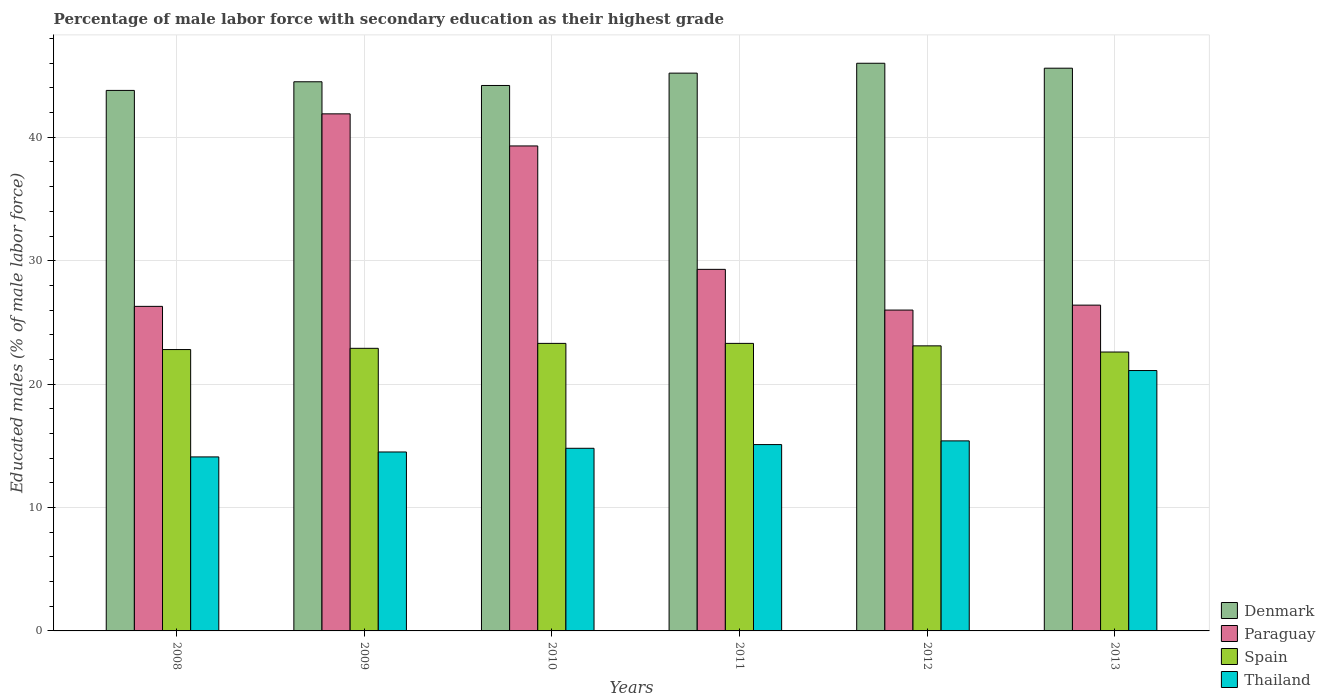How many different coloured bars are there?
Offer a terse response. 4. How many groups of bars are there?
Your response must be concise. 6. Are the number of bars per tick equal to the number of legend labels?
Your answer should be compact. Yes. How many bars are there on the 5th tick from the left?
Your response must be concise. 4. What is the label of the 5th group of bars from the left?
Provide a short and direct response. 2012. What is the percentage of male labor force with secondary education in Paraguay in 2008?
Make the answer very short. 26.3. Across all years, what is the minimum percentage of male labor force with secondary education in Thailand?
Your answer should be compact. 14.1. In which year was the percentage of male labor force with secondary education in Paraguay maximum?
Your answer should be very brief. 2009. In which year was the percentage of male labor force with secondary education in Spain minimum?
Keep it short and to the point. 2013. What is the total percentage of male labor force with secondary education in Denmark in the graph?
Make the answer very short. 269.3. What is the difference between the percentage of male labor force with secondary education in Thailand in 2010 and that in 2011?
Ensure brevity in your answer.  -0.3. What is the difference between the percentage of male labor force with secondary education in Denmark in 2010 and the percentage of male labor force with secondary education in Spain in 2013?
Offer a terse response. 21.6. What is the average percentage of male labor force with secondary education in Denmark per year?
Offer a very short reply. 44.88. In the year 2012, what is the difference between the percentage of male labor force with secondary education in Denmark and percentage of male labor force with secondary education in Spain?
Ensure brevity in your answer.  22.9. What is the ratio of the percentage of male labor force with secondary education in Denmark in 2012 to that in 2013?
Your answer should be compact. 1.01. Is the percentage of male labor force with secondary education in Denmark in 2009 less than that in 2012?
Your response must be concise. Yes. What is the difference between the highest and the second highest percentage of male labor force with secondary education in Thailand?
Offer a terse response. 5.7. What is the difference between the highest and the lowest percentage of male labor force with secondary education in Spain?
Keep it short and to the point. 0.7. Is the sum of the percentage of male labor force with secondary education in Paraguay in 2010 and 2013 greater than the maximum percentage of male labor force with secondary education in Spain across all years?
Your response must be concise. Yes. What does the 2nd bar from the right in 2013 represents?
Offer a very short reply. Spain. Is it the case that in every year, the sum of the percentage of male labor force with secondary education in Denmark and percentage of male labor force with secondary education in Thailand is greater than the percentage of male labor force with secondary education in Spain?
Your answer should be compact. Yes. Are all the bars in the graph horizontal?
Keep it short and to the point. No. Are the values on the major ticks of Y-axis written in scientific E-notation?
Your answer should be compact. No. What is the title of the graph?
Your response must be concise. Percentage of male labor force with secondary education as their highest grade. What is the label or title of the Y-axis?
Provide a short and direct response. Educated males (% of male labor force). What is the Educated males (% of male labor force) of Denmark in 2008?
Your answer should be very brief. 43.8. What is the Educated males (% of male labor force) of Paraguay in 2008?
Your answer should be compact. 26.3. What is the Educated males (% of male labor force) in Spain in 2008?
Keep it short and to the point. 22.8. What is the Educated males (% of male labor force) in Thailand in 2008?
Your response must be concise. 14.1. What is the Educated males (% of male labor force) in Denmark in 2009?
Keep it short and to the point. 44.5. What is the Educated males (% of male labor force) in Paraguay in 2009?
Make the answer very short. 41.9. What is the Educated males (% of male labor force) of Spain in 2009?
Ensure brevity in your answer.  22.9. What is the Educated males (% of male labor force) in Thailand in 2009?
Offer a very short reply. 14.5. What is the Educated males (% of male labor force) of Denmark in 2010?
Make the answer very short. 44.2. What is the Educated males (% of male labor force) of Paraguay in 2010?
Offer a very short reply. 39.3. What is the Educated males (% of male labor force) in Spain in 2010?
Offer a terse response. 23.3. What is the Educated males (% of male labor force) in Thailand in 2010?
Provide a succinct answer. 14.8. What is the Educated males (% of male labor force) of Denmark in 2011?
Offer a very short reply. 45.2. What is the Educated males (% of male labor force) in Paraguay in 2011?
Give a very brief answer. 29.3. What is the Educated males (% of male labor force) in Spain in 2011?
Keep it short and to the point. 23.3. What is the Educated males (% of male labor force) in Thailand in 2011?
Give a very brief answer. 15.1. What is the Educated males (% of male labor force) of Spain in 2012?
Offer a very short reply. 23.1. What is the Educated males (% of male labor force) in Thailand in 2012?
Ensure brevity in your answer.  15.4. What is the Educated males (% of male labor force) of Denmark in 2013?
Give a very brief answer. 45.6. What is the Educated males (% of male labor force) of Paraguay in 2013?
Provide a short and direct response. 26.4. What is the Educated males (% of male labor force) in Spain in 2013?
Offer a terse response. 22.6. What is the Educated males (% of male labor force) in Thailand in 2013?
Offer a terse response. 21.1. Across all years, what is the maximum Educated males (% of male labor force) in Paraguay?
Provide a short and direct response. 41.9. Across all years, what is the maximum Educated males (% of male labor force) in Spain?
Your answer should be very brief. 23.3. Across all years, what is the maximum Educated males (% of male labor force) in Thailand?
Offer a terse response. 21.1. Across all years, what is the minimum Educated males (% of male labor force) in Denmark?
Provide a short and direct response. 43.8. Across all years, what is the minimum Educated males (% of male labor force) in Paraguay?
Provide a succinct answer. 26. Across all years, what is the minimum Educated males (% of male labor force) of Spain?
Your answer should be compact. 22.6. Across all years, what is the minimum Educated males (% of male labor force) in Thailand?
Offer a terse response. 14.1. What is the total Educated males (% of male labor force) of Denmark in the graph?
Offer a very short reply. 269.3. What is the total Educated males (% of male labor force) of Paraguay in the graph?
Make the answer very short. 189.2. What is the total Educated males (% of male labor force) in Spain in the graph?
Your answer should be very brief. 138. What is the difference between the Educated males (% of male labor force) in Denmark in 2008 and that in 2009?
Give a very brief answer. -0.7. What is the difference between the Educated males (% of male labor force) of Paraguay in 2008 and that in 2009?
Offer a terse response. -15.6. What is the difference between the Educated males (% of male labor force) in Thailand in 2008 and that in 2009?
Give a very brief answer. -0.4. What is the difference between the Educated males (% of male labor force) of Paraguay in 2008 and that in 2010?
Your response must be concise. -13. What is the difference between the Educated males (% of male labor force) in Spain in 2008 and that in 2010?
Your answer should be compact. -0.5. What is the difference between the Educated males (% of male labor force) of Denmark in 2008 and that in 2011?
Your answer should be compact. -1.4. What is the difference between the Educated males (% of male labor force) of Paraguay in 2008 and that in 2011?
Provide a short and direct response. -3. What is the difference between the Educated males (% of male labor force) in Spain in 2008 and that in 2011?
Offer a very short reply. -0.5. What is the difference between the Educated males (% of male labor force) in Thailand in 2008 and that in 2011?
Ensure brevity in your answer.  -1. What is the difference between the Educated males (% of male labor force) of Denmark in 2008 and that in 2012?
Make the answer very short. -2.2. What is the difference between the Educated males (% of male labor force) of Thailand in 2008 and that in 2012?
Your response must be concise. -1.3. What is the difference between the Educated males (% of male labor force) of Denmark in 2008 and that in 2013?
Provide a succinct answer. -1.8. What is the difference between the Educated males (% of male labor force) of Paraguay in 2008 and that in 2013?
Provide a short and direct response. -0.1. What is the difference between the Educated males (% of male labor force) of Spain in 2008 and that in 2013?
Offer a terse response. 0.2. What is the difference between the Educated males (% of male labor force) of Thailand in 2008 and that in 2013?
Your response must be concise. -7. What is the difference between the Educated males (% of male labor force) in Denmark in 2009 and that in 2010?
Your answer should be very brief. 0.3. What is the difference between the Educated males (% of male labor force) in Thailand in 2009 and that in 2010?
Offer a very short reply. -0.3. What is the difference between the Educated males (% of male labor force) of Paraguay in 2009 and that in 2011?
Your response must be concise. 12.6. What is the difference between the Educated males (% of male labor force) of Spain in 2009 and that in 2011?
Ensure brevity in your answer.  -0.4. What is the difference between the Educated males (% of male labor force) in Thailand in 2009 and that in 2011?
Offer a very short reply. -0.6. What is the difference between the Educated males (% of male labor force) of Spain in 2009 and that in 2012?
Make the answer very short. -0.2. What is the difference between the Educated males (% of male labor force) of Thailand in 2009 and that in 2012?
Give a very brief answer. -0.9. What is the difference between the Educated males (% of male labor force) of Spain in 2009 and that in 2013?
Your response must be concise. 0.3. What is the difference between the Educated males (% of male labor force) of Thailand in 2010 and that in 2011?
Offer a terse response. -0.3. What is the difference between the Educated males (% of male labor force) of Paraguay in 2010 and that in 2012?
Keep it short and to the point. 13.3. What is the difference between the Educated males (% of male labor force) of Denmark in 2011 and that in 2012?
Give a very brief answer. -0.8. What is the difference between the Educated males (% of male labor force) in Spain in 2011 and that in 2012?
Offer a very short reply. 0.2. What is the difference between the Educated males (% of male labor force) in Paraguay in 2011 and that in 2013?
Offer a very short reply. 2.9. What is the difference between the Educated males (% of male labor force) in Thailand in 2011 and that in 2013?
Provide a succinct answer. -6. What is the difference between the Educated males (% of male labor force) in Denmark in 2012 and that in 2013?
Keep it short and to the point. 0.4. What is the difference between the Educated males (% of male labor force) in Spain in 2012 and that in 2013?
Provide a short and direct response. 0.5. What is the difference between the Educated males (% of male labor force) of Thailand in 2012 and that in 2013?
Give a very brief answer. -5.7. What is the difference between the Educated males (% of male labor force) of Denmark in 2008 and the Educated males (% of male labor force) of Spain in 2009?
Keep it short and to the point. 20.9. What is the difference between the Educated males (% of male labor force) of Denmark in 2008 and the Educated males (% of male labor force) of Thailand in 2009?
Keep it short and to the point. 29.3. What is the difference between the Educated males (% of male labor force) of Paraguay in 2008 and the Educated males (% of male labor force) of Thailand in 2009?
Provide a short and direct response. 11.8. What is the difference between the Educated males (% of male labor force) in Spain in 2008 and the Educated males (% of male labor force) in Thailand in 2009?
Provide a succinct answer. 8.3. What is the difference between the Educated males (% of male labor force) in Denmark in 2008 and the Educated males (% of male labor force) in Paraguay in 2010?
Ensure brevity in your answer.  4.5. What is the difference between the Educated males (% of male labor force) of Paraguay in 2008 and the Educated males (% of male labor force) of Spain in 2010?
Offer a terse response. 3. What is the difference between the Educated males (% of male labor force) of Spain in 2008 and the Educated males (% of male labor force) of Thailand in 2010?
Offer a terse response. 8. What is the difference between the Educated males (% of male labor force) in Denmark in 2008 and the Educated males (% of male labor force) in Thailand in 2011?
Offer a very short reply. 28.7. What is the difference between the Educated males (% of male labor force) in Paraguay in 2008 and the Educated males (% of male labor force) in Spain in 2011?
Ensure brevity in your answer.  3. What is the difference between the Educated males (% of male labor force) in Paraguay in 2008 and the Educated males (% of male labor force) in Thailand in 2011?
Provide a short and direct response. 11.2. What is the difference between the Educated males (% of male labor force) of Spain in 2008 and the Educated males (% of male labor force) of Thailand in 2011?
Make the answer very short. 7.7. What is the difference between the Educated males (% of male labor force) of Denmark in 2008 and the Educated males (% of male labor force) of Spain in 2012?
Provide a short and direct response. 20.7. What is the difference between the Educated males (% of male labor force) of Denmark in 2008 and the Educated males (% of male labor force) of Thailand in 2012?
Give a very brief answer. 28.4. What is the difference between the Educated males (% of male labor force) in Paraguay in 2008 and the Educated males (% of male labor force) in Spain in 2012?
Your answer should be very brief. 3.2. What is the difference between the Educated males (% of male labor force) in Paraguay in 2008 and the Educated males (% of male labor force) in Thailand in 2012?
Provide a succinct answer. 10.9. What is the difference between the Educated males (% of male labor force) of Spain in 2008 and the Educated males (% of male labor force) of Thailand in 2012?
Offer a very short reply. 7.4. What is the difference between the Educated males (% of male labor force) in Denmark in 2008 and the Educated males (% of male labor force) in Spain in 2013?
Ensure brevity in your answer.  21.2. What is the difference between the Educated males (% of male labor force) in Denmark in 2008 and the Educated males (% of male labor force) in Thailand in 2013?
Your answer should be compact. 22.7. What is the difference between the Educated males (% of male labor force) of Denmark in 2009 and the Educated males (% of male labor force) of Spain in 2010?
Your answer should be compact. 21.2. What is the difference between the Educated males (% of male labor force) of Denmark in 2009 and the Educated males (% of male labor force) of Thailand in 2010?
Make the answer very short. 29.7. What is the difference between the Educated males (% of male labor force) of Paraguay in 2009 and the Educated males (% of male labor force) of Spain in 2010?
Keep it short and to the point. 18.6. What is the difference between the Educated males (% of male labor force) in Paraguay in 2009 and the Educated males (% of male labor force) in Thailand in 2010?
Your response must be concise. 27.1. What is the difference between the Educated males (% of male labor force) in Spain in 2009 and the Educated males (% of male labor force) in Thailand in 2010?
Keep it short and to the point. 8.1. What is the difference between the Educated males (% of male labor force) of Denmark in 2009 and the Educated males (% of male labor force) of Spain in 2011?
Provide a short and direct response. 21.2. What is the difference between the Educated males (% of male labor force) of Denmark in 2009 and the Educated males (% of male labor force) of Thailand in 2011?
Keep it short and to the point. 29.4. What is the difference between the Educated males (% of male labor force) of Paraguay in 2009 and the Educated males (% of male labor force) of Thailand in 2011?
Your answer should be compact. 26.8. What is the difference between the Educated males (% of male labor force) of Spain in 2009 and the Educated males (% of male labor force) of Thailand in 2011?
Give a very brief answer. 7.8. What is the difference between the Educated males (% of male labor force) of Denmark in 2009 and the Educated males (% of male labor force) of Paraguay in 2012?
Offer a terse response. 18.5. What is the difference between the Educated males (% of male labor force) in Denmark in 2009 and the Educated males (% of male labor force) in Spain in 2012?
Ensure brevity in your answer.  21.4. What is the difference between the Educated males (% of male labor force) of Denmark in 2009 and the Educated males (% of male labor force) of Thailand in 2012?
Your answer should be very brief. 29.1. What is the difference between the Educated males (% of male labor force) of Paraguay in 2009 and the Educated males (% of male labor force) of Spain in 2012?
Offer a very short reply. 18.8. What is the difference between the Educated males (% of male labor force) in Denmark in 2009 and the Educated males (% of male labor force) in Paraguay in 2013?
Your answer should be compact. 18.1. What is the difference between the Educated males (% of male labor force) of Denmark in 2009 and the Educated males (% of male labor force) of Spain in 2013?
Ensure brevity in your answer.  21.9. What is the difference between the Educated males (% of male labor force) of Denmark in 2009 and the Educated males (% of male labor force) of Thailand in 2013?
Your response must be concise. 23.4. What is the difference between the Educated males (% of male labor force) in Paraguay in 2009 and the Educated males (% of male labor force) in Spain in 2013?
Your answer should be compact. 19.3. What is the difference between the Educated males (% of male labor force) in Paraguay in 2009 and the Educated males (% of male labor force) in Thailand in 2013?
Your answer should be compact. 20.8. What is the difference between the Educated males (% of male labor force) of Spain in 2009 and the Educated males (% of male labor force) of Thailand in 2013?
Your answer should be compact. 1.8. What is the difference between the Educated males (% of male labor force) in Denmark in 2010 and the Educated males (% of male labor force) in Spain in 2011?
Ensure brevity in your answer.  20.9. What is the difference between the Educated males (% of male labor force) of Denmark in 2010 and the Educated males (% of male labor force) of Thailand in 2011?
Ensure brevity in your answer.  29.1. What is the difference between the Educated males (% of male labor force) of Paraguay in 2010 and the Educated males (% of male labor force) of Spain in 2011?
Give a very brief answer. 16. What is the difference between the Educated males (% of male labor force) of Paraguay in 2010 and the Educated males (% of male labor force) of Thailand in 2011?
Offer a terse response. 24.2. What is the difference between the Educated males (% of male labor force) of Spain in 2010 and the Educated males (% of male labor force) of Thailand in 2011?
Provide a succinct answer. 8.2. What is the difference between the Educated males (% of male labor force) in Denmark in 2010 and the Educated males (% of male labor force) in Paraguay in 2012?
Offer a terse response. 18.2. What is the difference between the Educated males (% of male labor force) in Denmark in 2010 and the Educated males (% of male labor force) in Spain in 2012?
Ensure brevity in your answer.  21.1. What is the difference between the Educated males (% of male labor force) of Denmark in 2010 and the Educated males (% of male labor force) of Thailand in 2012?
Keep it short and to the point. 28.8. What is the difference between the Educated males (% of male labor force) in Paraguay in 2010 and the Educated males (% of male labor force) in Thailand in 2012?
Offer a terse response. 23.9. What is the difference between the Educated males (% of male labor force) in Denmark in 2010 and the Educated males (% of male labor force) in Spain in 2013?
Offer a terse response. 21.6. What is the difference between the Educated males (% of male labor force) of Denmark in 2010 and the Educated males (% of male labor force) of Thailand in 2013?
Provide a succinct answer. 23.1. What is the difference between the Educated males (% of male labor force) in Paraguay in 2010 and the Educated males (% of male labor force) in Thailand in 2013?
Make the answer very short. 18.2. What is the difference between the Educated males (% of male labor force) in Spain in 2010 and the Educated males (% of male labor force) in Thailand in 2013?
Give a very brief answer. 2.2. What is the difference between the Educated males (% of male labor force) in Denmark in 2011 and the Educated males (% of male labor force) in Paraguay in 2012?
Your response must be concise. 19.2. What is the difference between the Educated males (% of male labor force) of Denmark in 2011 and the Educated males (% of male labor force) of Spain in 2012?
Offer a very short reply. 22.1. What is the difference between the Educated males (% of male labor force) of Denmark in 2011 and the Educated males (% of male labor force) of Thailand in 2012?
Offer a terse response. 29.8. What is the difference between the Educated males (% of male labor force) in Paraguay in 2011 and the Educated males (% of male labor force) in Spain in 2012?
Offer a very short reply. 6.2. What is the difference between the Educated males (% of male labor force) of Paraguay in 2011 and the Educated males (% of male labor force) of Thailand in 2012?
Ensure brevity in your answer.  13.9. What is the difference between the Educated males (% of male labor force) in Spain in 2011 and the Educated males (% of male labor force) in Thailand in 2012?
Your response must be concise. 7.9. What is the difference between the Educated males (% of male labor force) of Denmark in 2011 and the Educated males (% of male labor force) of Paraguay in 2013?
Offer a terse response. 18.8. What is the difference between the Educated males (% of male labor force) of Denmark in 2011 and the Educated males (% of male labor force) of Spain in 2013?
Offer a very short reply. 22.6. What is the difference between the Educated males (% of male labor force) of Denmark in 2011 and the Educated males (% of male labor force) of Thailand in 2013?
Provide a succinct answer. 24.1. What is the difference between the Educated males (% of male labor force) in Denmark in 2012 and the Educated males (% of male labor force) in Paraguay in 2013?
Your answer should be compact. 19.6. What is the difference between the Educated males (% of male labor force) of Denmark in 2012 and the Educated males (% of male labor force) of Spain in 2013?
Offer a very short reply. 23.4. What is the difference between the Educated males (% of male labor force) of Denmark in 2012 and the Educated males (% of male labor force) of Thailand in 2013?
Give a very brief answer. 24.9. What is the difference between the Educated males (% of male labor force) in Paraguay in 2012 and the Educated males (% of male labor force) in Spain in 2013?
Offer a very short reply. 3.4. What is the average Educated males (% of male labor force) in Denmark per year?
Your answer should be very brief. 44.88. What is the average Educated males (% of male labor force) of Paraguay per year?
Give a very brief answer. 31.53. What is the average Educated males (% of male labor force) in Spain per year?
Provide a short and direct response. 23. What is the average Educated males (% of male labor force) in Thailand per year?
Give a very brief answer. 15.83. In the year 2008, what is the difference between the Educated males (% of male labor force) in Denmark and Educated males (% of male labor force) in Paraguay?
Give a very brief answer. 17.5. In the year 2008, what is the difference between the Educated males (% of male labor force) of Denmark and Educated males (% of male labor force) of Thailand?
Keep it short and to the point. 29.7. In the year 2008, what is the difference between the Educated males (% of male labor force) of Paraguay and Educated males (% of male labor force) of Spain?
Keep it short and to the point. 3.5. In the year 2009, what is the difference between the Educated males (% of male labor force) in Denmark and Educated males (% of male labor force) in Spain?
Ensure brevity in your answer.  21.6. In the year 2009, what is the difference between the Educated males (% of male labor force) of Denmark and Educated males (% of male labor force) of Thailand?
Your answer should be very brief. 30. In the year 2009, what is the difference between the Educated males (% of male labor force) of Paraguay and Educated males (% of male labor force) of Spain?
Give a very brief answer. 19. In the year 2009, what is the difference between the Educated males (% of male labor force) of Paraguay and Educated males (% of male labor force) of Thailand?
Make the answer very short. 27.4. In the year 2010, what is the difference between the Educated males (% of male labor force) of Denmark and Educated males (% of male labor force) of Spain?
Keep it short and to the point. 20.9. In the year 2010, what is the difference between the Educated males (% of male labor force) in Denmark and Educated males (% of male labor force) in Thailand?
Give a very brief answer. 29.4. In the year 2010, what is the difference between the Educated males (% of male labor force) of Paraguay and Educated males (% of male labor force) of Thailand?
Your response must be concise. 24.5. In the year 2010, what is the difference between the Educated males (% of male labor force) of Spain and Educated males (% of male labor force) of Thailand?
Your answer should be compact. 8.5. In the year 2011, what is the difference between the Educated males (% of male labor force) in Denmark and Educated males (% of male labor force) in Spain?
Provide a short and direct response. 21.9. In the year 2011, what is the difference between the Educated males (% of male labor force) of Denmark and Educated males (% of male labor force) of Thailand?
Make the answer very short. 30.1. In the year 2011, what is the difference between the Educated males (% of male labor force) of Paraguay and Educated males (% of male labor force) of Spain?
Offer a terse response. 6. In the year 2011, what is the difference between the Educated males (% of male labor force) of Spain and Educated males (% of male labor force) of Thailand?
Offer a terse response. 8.2. In the year 2012, what is the difference between the Educated males (% of male labor force) of Denmark and Educated males (% of male labor force) of Paraguay?
Give a very brief answer. 20. In the year 2012, what is the difference between the Educated males (% of male labor force) of Denmark and Educated males (% of male labor force) of Spain?
Your answer should be compact. 22.9. In the year 2012, what is the difference between the Educated males (% of male labor force) of Denmark and Educated males (% of male labor force) of Thailand?
Your answer should be compact. 30.6. In the year 2012, what is the difference between the Educated males (% of male labor force) in Paraguay and Educated males (% of male labor force) in Spain?
Make the answer very short. 2.9. In the year 2012, what is the difference between the Educated males (% of male labor force) in Paraguay and Educated males (% of male labor force) in Thailand?
Give a very brief answer. 10.6. In the year 2013, what is the difference between the Educated males (% of male labor force) of Denmark and Educated males (% of male labor force) of Thailand?
Provide a succinct answer. 24.5. In the year 2013, what is the difference between the Educated males (% of male labor force) in Paraguay and Educated males (% of male labor force) in Spain?
Provide a succinct answer. 3.8. In the year 2013, what is the difference between the Educated males (% of male labor force) of Paraguay and Educated males (% of male labor force) of Thailand?
Ensure brevity in your answer.  5.3. In the year 2013, what is the difference between the Educated males (% of male labor force) of Spain and Educated males (% of male labor force) of Thailand?
Ensure brevity in your answer.  1.5. What is the ratio of the Educated males (% of male labor force) in Denmark in 2008 to that in 2009?
Keep it short and to the point. 0.98. What is the ratio of the Educated males (% of male labor force) in Paraguay in 2008 to that in 2009?
Your answer should be very brief. 0.63. What is the ratio of the Educated males (% of male labor force) in Spain in 2008 to that in 2009?
Ensure brevity in your answer.  1. What is the ratio of the Educated males (% of male labor force) of Thailand in 2008 to that in 2009?
Provide a succinct answer. 0.97. What is the ratio of the Educated males (% of male labor force) in Paraguay in 2008 to that in 2010?
Make the answer very short. 0.67. What is the ratio of the Educated males (% of male labor force) of Spain in 2008 to that in 2010?
Offer a terse response. 0.98. What is the ratio of the Educated males (% of male labor force) of Thailand in 2008 to that in 2010?
Provide a succinct answer. 0.95. What is the ratio of the Educated males (% of male labor force) of Denmark in 2008 to that in 2011?
Offer a very short reply. 0.97. What is the ratio of the Educated males (% of male labor force) in Paraguay in 2008 to that in 2011?
Ensure brevity in your answer.  0.9. What is the ratio of the Educated males (% of male labor force) in Spain in 2008 to that in 2011?
Keep it short and to the point. 0.98. What is the ratio of the Educated males (% of male labor force) of Thailand in 2008 to that in 2011?
Ensure brevity in your answer.  0.93. What is the ratio of the Educated males (% of male labor force) in Denmark in 2008 to that in 2012?
Provide a succinct answer. 0.95. What is the ratio of the Educated males (% of male labor force) in Paraguay in 2008 to that in 2012?
Your answer should be compact. 1.01. What is the ratio of the Educated males (% of male labor force) of Thailand in 2008 to that in 2012?
Ensure brevity in your answer.  0.92. What is the ratio of the Educated males (% of male labor force) of Denmark in 2008 to that in 2013?
Offer a very short reply. 0.96. What is the ratio of the Educated males (% of male labor force) of Spain in 2008 to that in 2013?
Give a very brief answer. 1.01. What is the ratio of the Educated males (% of male labor force) of Thailand in 2008 to that in 2013?
Ensure brevity in your answer.  0.67. What is the ratio of the Educated males (% of male labor force) in Denmark in 2009 to that in 2010?
Provide a short and direct response. 1.01. What is the ratio of the Educated males (% of male labor force) in Paraguay in 2009 to that in 2010?
Your response must be concise. 1.07. What is the ratio of the Educated males (% of male labor force) of Spain in 2009 to that in 2010?
Your answer should be very brief. 0.98. What is the ratio of the Educated males (% of male labor force) in Thailand in 2009 to that in 2010?
Your answer should be compact. 0.98. What is the ratio of the Educated males (% of male labor force) of Denmark in 2009 to that in 2011?
Keep it short and to the point. 0.98. What is the ratio of the Educated males (% of male labor force) in Paraguay in 2009 to that in 2011?
Provide a succinct answer. 1.43. What is the ratio of the Educated males (% of male labor force) in Spain in 2009 to that in 2011?
Offer a very short reply. 0.98. What is the ratio of the Educated males (% of male labor force) of Thailand in 2009 to that in 2011?
Offer a very short reply. 0.96. What is the ratio of the Educated males (% of male labor force) in Denmark in 2009 to that in 2012?
Give a very brief answer. 0.97. What is the ratio of the Educated males (% of male labor force) in Paraguay in 2009 to that in 2012?
Provide a short and direct response. 1.61. What is the ratio of the Educated males (% of male labor force) of Spain in 2009 to that in 2012?
Provide a short and direct response. 0.99. What is the ratio of the Educated males (% of male labor force) in Thailand in 2009 to that in 2012?
Provide a succinct answer. 0.94. What is the ratio of the Educated males (% of male labor force) in Denmark in 2009 to that in 2013?
Provide a short and direct response. 0.98. What is the ratio of the Educated males (% of male labor force) of Paraguay in 2009 to that in 2013?
Offer a terse response. 1.59. What is the ratio of the Educated males (% of male labor force) of Spain in 2009 to that in 2013?
Give a very brief answer. 1.01. What is the ratio of the Educated males (% of male labor force) in Thailand in 2009 to that in 2013?
Make the answer very short. 0.69. What is the ratio of the Educated males (% of male labor force) of Denmark in 2010 to that in 2011?
Keep it short and to the point. 0.98. What is the ratio of the Educated males (% of male labor force) in Paraguay in 2010 to that in 2011?
Ensure brevity in your answer.  1.34. What is the ratio of the Educated males (% of male labor force) of Thailand in 2010 to that in 2011?
Make the answer very short. 0.98. What is the ratio of the Educated males (% of male labor force) in Denmark in 2010 to that in 2012?
Give a very brief answer. 0.96. What is the ratio of the Educated males (% of male labor force) of Paraguay in 2010 to that in 2012?
Your response must be concise. 1.51. What is the ratio of the Educated males (% of male labor force) in Spain in 2010 to that in 2012?
Your response must be concise. 1.01. What is the ratio of the Educated males (% of male labor force) of Denmark in 2010 to that in 2013?
Offer a very short reply. 0.97. What is the ratio of the Educated males (% of male labor force) of Paraguay in 2010 to that in 2013?
Give a very brief answer. 1.49. What is the ratio of the Educated males (% of male labor force) of Spain in 2010 to that in 2013?
Offer a very short reply. 1.03. What is the ratio of the Educated males (% of male labor force) in Thailand in 2010 to that in 2013?
Offer a very short reply. 0.7. What is the ratio of the Educated males (% of male labor force) in Denmark in 2011 to that in 2012?
Provide a short and direct response. 0.98. What is the ratio of the Educated males (% of male labor force) of Paraguay in 2011 to that in 2012?
Offer a terse response. 1.13. What is the ratio of the Educated males (% of male labor force) of Spain in 2011 to that in 2012?
Your answer should be compact. 1.01. What is the ratio of the Educated males (% of male labor force) of Thailand in 2011 to that in 2012?
Your response must be concise. 0.98. What is the ratio of the Educated males (% of male labor force) in Denmark in 2011 to that in 2013?
Provide a succinct answer. 0.99. What is the ratio of the Educated males (% of male labor force) in Paraguay in 2011 to that in 2013?
Your answer should be very brief. 1.11. What is the ratio of the Educated males (% of male labor force) of Spain in 2011 to that in 2013?
Your answer should be compact. 1.03. What is the ratio of the Educated males (% of male labor force) in Thailand in 2011 to that in 2013?
Give a very brief answer. 0.72. What is the ratio of the Educated males (% of male labor force) in Denmark in 2012 to that in 2013?
Give a very brief answer. 1.01. What is the ratio of the Educated males (% of male labor force) of Spain in 2012 to that in 2013?
Provide a succinct answer. 1.02. What is the ratio of the Educated males (% of male labor force) in Thailand in 2012 to that in 2013?
Offer a very short reply. 0.73. What is the difference between the highest and the second highest Educated males (% of male labor force) of Denmark?
Provide a succinct answer. 0.4. 